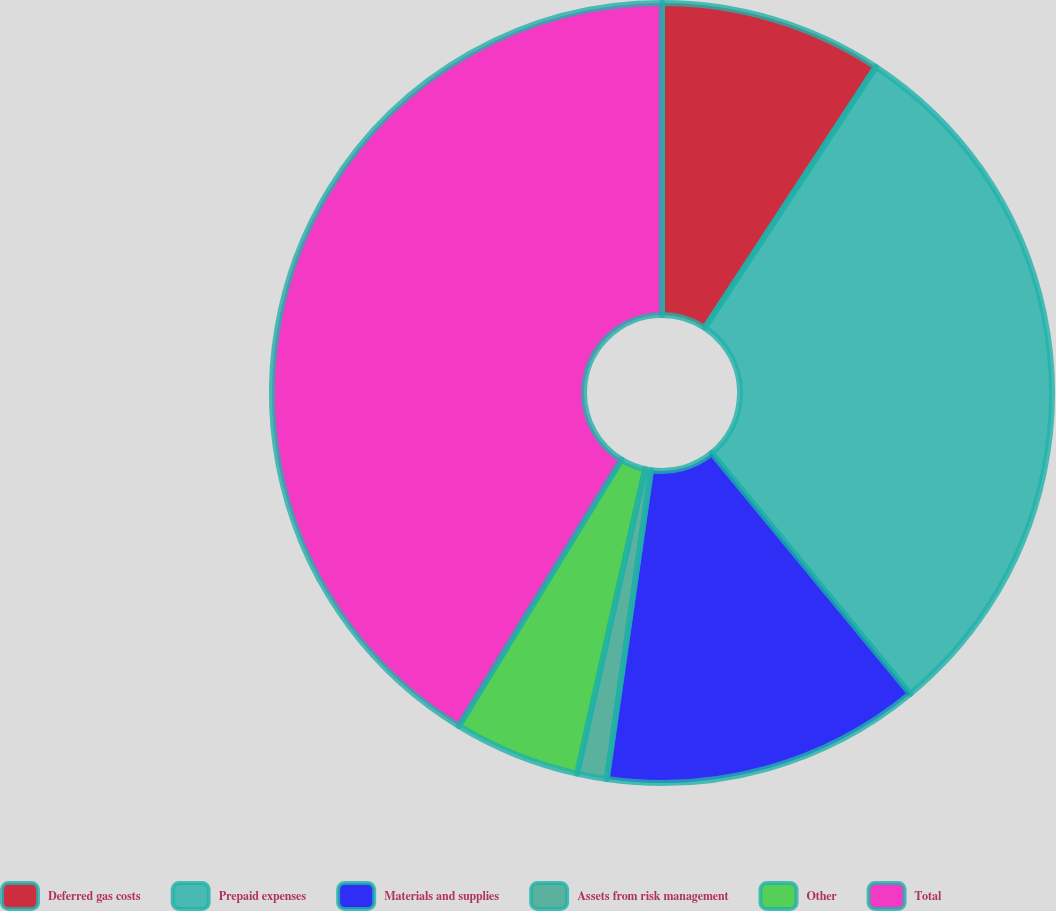<chart> <loc_0><loc_0><loc_500><loc_500><pie_chart><fcel>Deferred gas costs<fcel>Prepaid expenses<fcel>Materials and supplies<fcel>Assets from risk management<fcel>Other<fcel>Total<nl><fcel>9.24%<fcel>29.79%<fcel>13.24%<fcel>1.23%<fcel>5.23%<fcel>41.28%<nl></chart> 